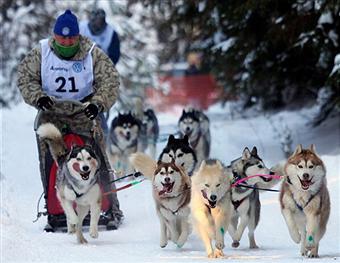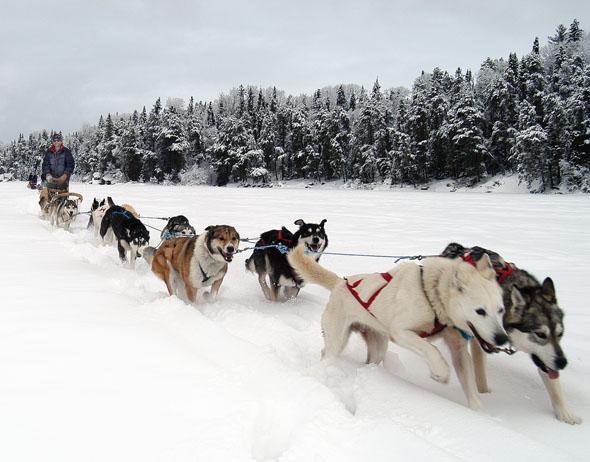The first image is the image on the left, the second image is the image on the right. Analyze the images presented: Is the assertion "Someone is wearing a vest with a number in at least one of the images." valid? Answer yes or no. Yes. The first image is the image on the left, the second image is the image on the right. Evaluate the accuracy of this statement regarding the images: "An image shows one dog team moving diagonally across the snow, with snow-covered evergreens in the background and no bystanders.". Is it true? Answer yes or no. Yes. 